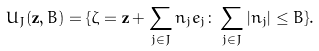Convert formula to latex. <formula><loc_0><loc_0><loc_500><loc_500>U _ { J } ( { \mathbf z } , B ) = \{ { \mathbf \zeta } = { \mathbf z } + \sum _ { j \in J } n _ { j } e _ { j } \colon \sum _ { j \in J } | n _ { j } | \leq B \} .</formula> 